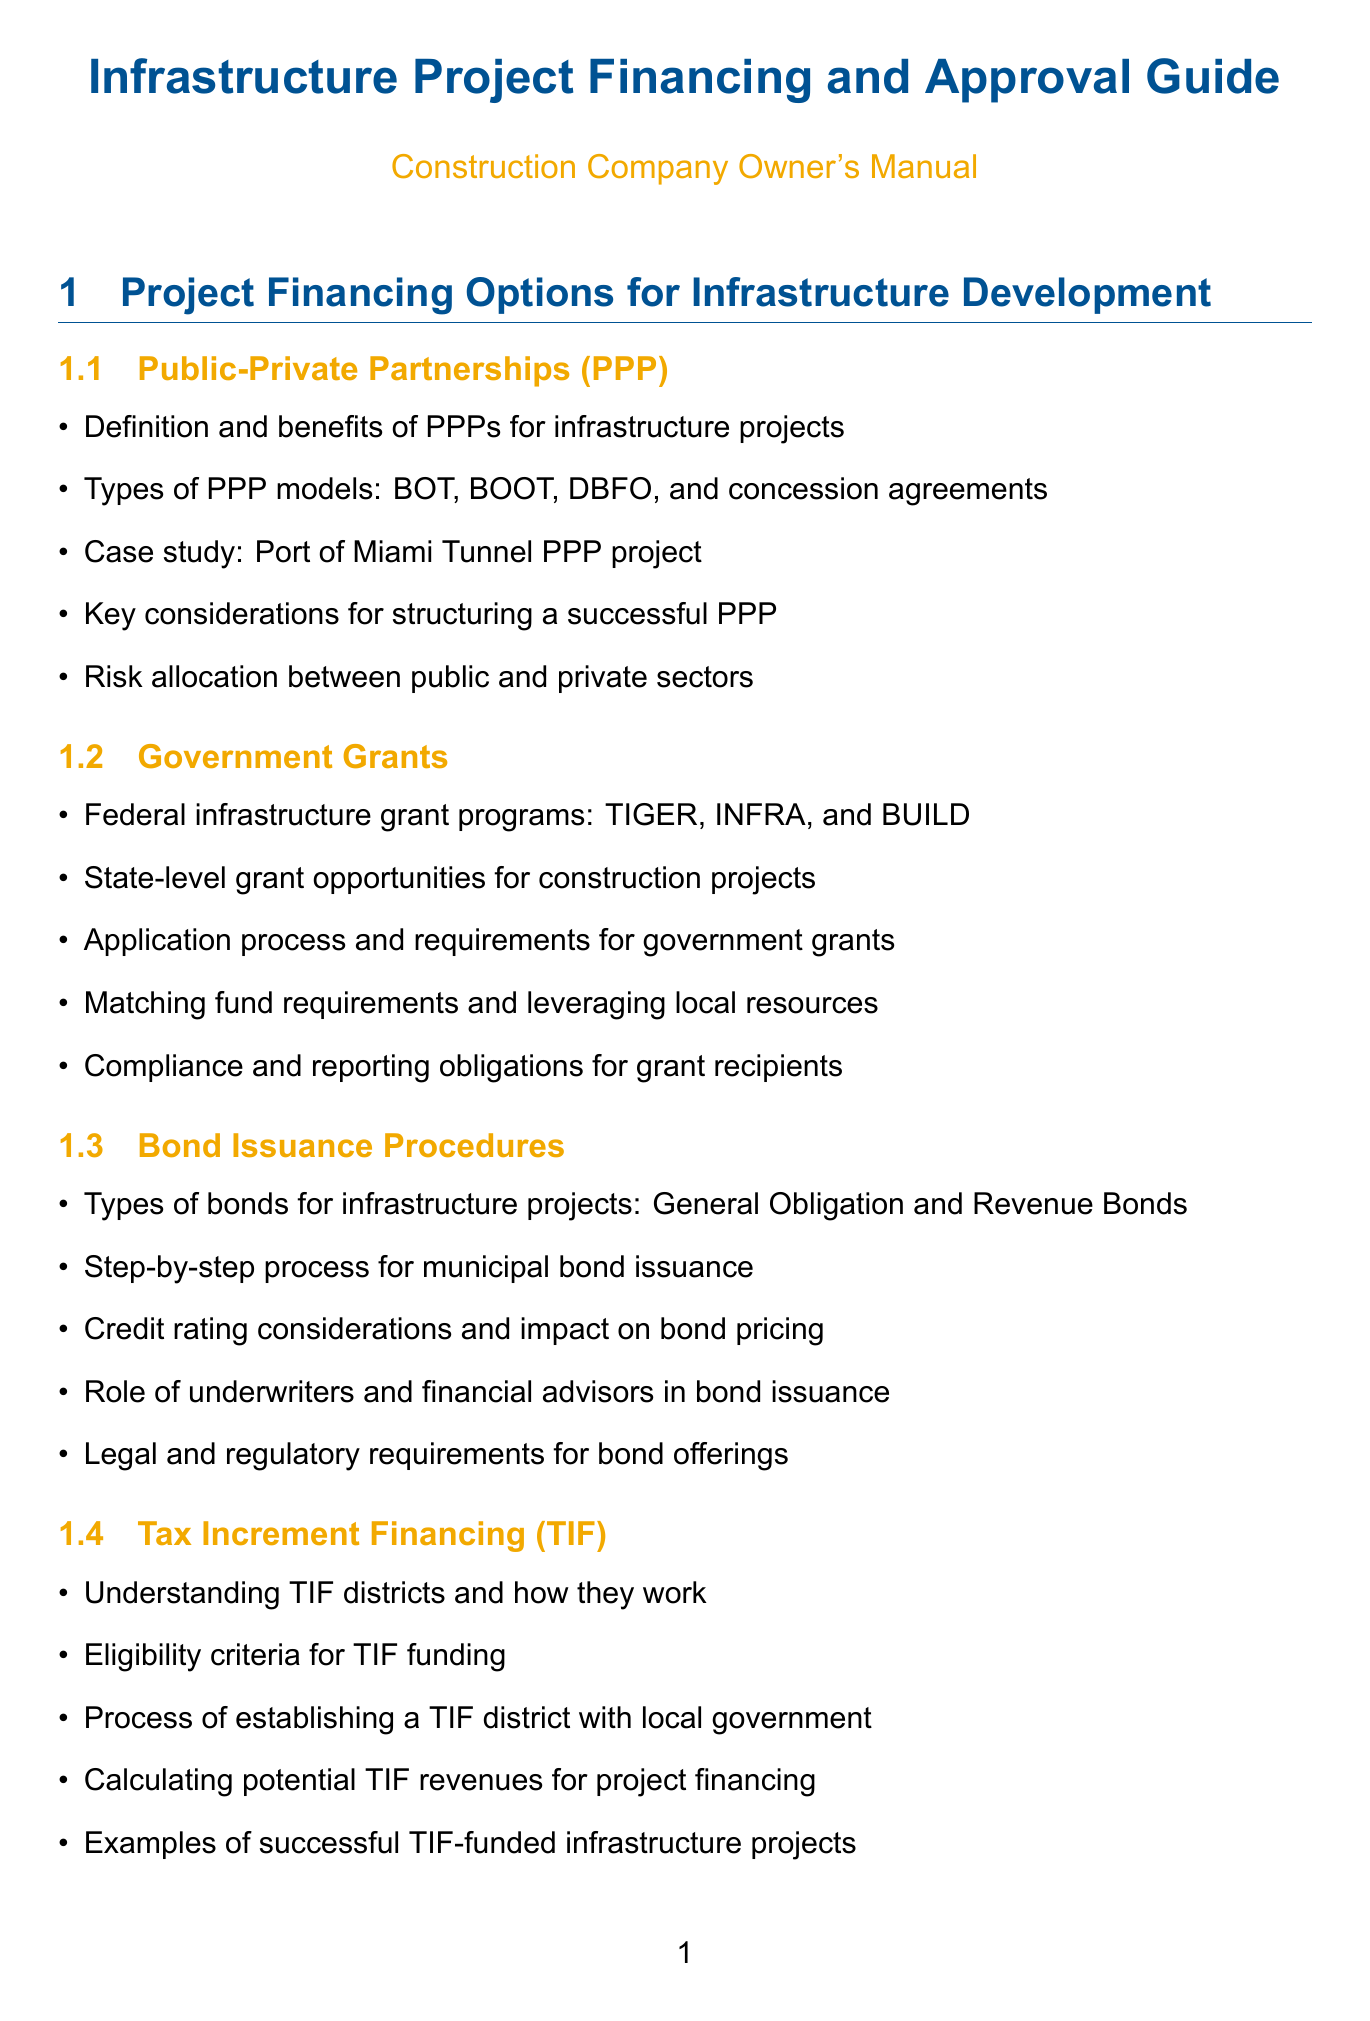What are the types of PPP models? The document lists specific types of PPP models under the “Public-Private Partnerships (PPP)” section.
Answer: BOT, BOOT, DBFO, concession agreements What federal grant programs are mentioned? The “Government Grants” section outlines various federal programs relevant to infrastructure projects.
Answer: TIGER, INFRA, BUILD What is the role of underwriters in bond issuance? The document discusses the responsibilities and contributions of underwriters in the “Bond Issuance Procedures” section.
Answer: Underwriters and financial advisors What is a key consideration for structuring a successful PPP? The document highlights important factors to keep in mind for effective PPP structuring.
Answer: Risk allocation between public and private sectors What funding mechanism involves TIF districts? The relevant section of the document addresses a specific financing approach related to districts for funding.
Answer: Tax Increment Financing (TIF) What federal loan program relates to water infrastructure? The document identifies loan programs specifically focused on water infrastructure in the “Federal Loan Programs” section.
Answer: Water Infrastructure Finance and Innovation Act (WIFIA) What is a key component of an effective infrastructure project proposal? The “Developing a Compelling Project Proposal” section outlines essential elements in project proposals.
Answer: Feasibility studies and impact assessments What do KPIs stand for? The document explains the acronym used in project performance metrics under the “Performance Metrics and Evaluation” section.
Answer: Key performance indicators What type of bonds are General Obligation bonds? The document describes the types of bonds in the context of infrastructure projects.
Answer: Types of bonds for infrastructure projects 